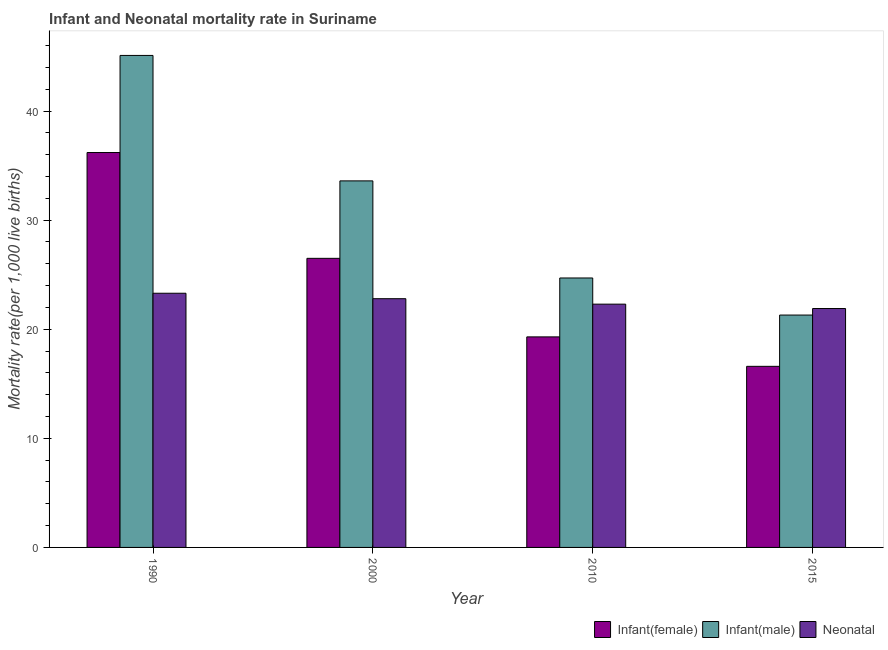How many groups of bars are there?
Give a very brief answer. 4. Are the number of bars on each tick of the X-axis equal?
Offer a terse response. Yes. How many bars are there on the 1st tick from the right?
Offer a very short reply. 3. What is the label of the 1st group of bars from the left?
Offer a very short reply. 1990. In how many cases, is the number of bars for a given year not equal to the number of legend labels?
Provide a short and direct response. 0. What is the neonatal mortality rate in 2010?
Keep it short and to the point. 22.3. Across all years, what is the maximum infant mortality rate(female)?
Ensure brevity in your answer.  36.2. Across all years, what is the minimum neonatal mortality rate?
Give a very brief answer. 21.9. In which year was the neonatal mortality rate maximum?
Provide a short and direct response. 1990. In which year was the infant mortality rate(female) minimum?
Your response must be concise. 2015. What is the total neonatal mortality rate in the graph?
Your response must be concise. 90.3. What is the difference between the neonatal mortality rate in 1990 and that in 2000?
Keep it short and to the point. 0.5. What is the difference between the neonatal mortality rate in 2015 and the infant mortality rate(male) in 2000?
Your response must be concise. -0.9. What is the average infant mortality rate(female) per year?
Ensure brevity in your answer.  24.65. What is the ratio of the infant mortality rate(male) in 2010 to that in 2015?
Your response must be concise. 1.16. Is the difference between the infant mortality rate(female) in 2000 and 2010 greater than the difference between the infant mortality rate(male) in 2000 and 2010?
Make the answer very short. No. What is the difference between the highest and the second highest infant mortality rate(female)?
Ensure brevity in your answer.  9.7. What is the difference between the highest and the lowest neonatal mortality rate?
Provide a short and direct response. 1.4. What does the 3rd bar from the left in 2000 represents?
Make the answer very short. Neonatal . What does the 2nd bar from the right in 2015 represents?
Your answer should be very brief. Infant(male). How many years are there in the graph?
Keep it short and to the point. 4. Does the graph contain grids?
Provide a short and direct response. No. Where does the legend appear in the graph?
Ensure brevity in your answer.  Bottom right. How many legend labels are there?
Provide a succinct answer. 3. How are the legend labels stacked?
Provide a short and direct response. Horizontal. What is the title of the graph?
Make the answer very short. Infant and Neonatal mortality rate in Suriname. What is the label or title of the Y-axis?
Your answer should be very brief. Mortality rate(per 1,0 live births). What is the Mortality rate(per 1,000 live births) in Infant(female) in 1990?
Keep it short and to the point. 36.2. What is the Mortality rate(per 1,000 live births) in Infant(male) in 1990?
Offer a very short reply. 45.1. What is the Mortality rate(per 1,000 live births) in Neonatal  in 1990?
Make the answer very short. 23.3. What is the Mortality rate(per 1,000 live births) in Infant(female) in 2000?
Your answer should be very brief. 26.5. What is the Mortality rate(per 1,000 live births) in Infant(male) in 2000?
Offer a very short reply. 33.6. What is the Mortality rate(per 1,000 live births) in Neonatal  in 2000?
Provide a succinct answer. 22.8. What is the Mortality rate(per 1,000 live births) in Infant(female) in 2010?
Your response must be concise. 19.3. What is the Mortality rate(per 1,000 live births) in Infant(male) in 2010?
Offer a very short reply. 24.7. What is the Mortality rate(per 1,000 live births) of Neonatal  in 2010?
Ensure brevity in your answer.  22.3. What is the Mortality rate(per 1,000 live births) of Infant(male) in 2015?
Make the answer very short. 21.3. What is the Mortality rate(per 1,000 live births) of Neonatal  in 2015?
Your answer should be compact. 21.9. Across all years, what is the maximum Mortality rate(per 1,000 live births) in Infant(female)?
Keep it short and to the point. 36.2. Across all years, what is the maximum Mortality rate(per 1,000 live births) in Infant(male)?
Make the answer very short. 45.1. Across all years, what is the maximum Mortality rate(per 1,000 live births) of Neonatal ?
Offer a very short reply. 23.3. Across all years, what is the minimum Mortality rate(per 1,000 live births) of Infant(female)?
Provide a short and direct response. 16.6. Across all years, what is the minimum Mortality rate(per 1,000 live births) of Infant(male)?
Your answer should be compact. 21.3. Across all years, what is the minimum Mortality rate(per 1,000 live births) in Neonatal ?
Your answer should be very brief. 21.9. What is the total Mortality rate(per 1,000 live births) in Infant(female) in the graph?
Provide a short and direct response. 98.6. What is the total Mortality rate(per 1,000 live births) of Infant(male) in the graph?
Your response must be concise. 124.7. What is the total Mortality rate(per 1,000 live births) in Neonatal  in the graph?
Give a very brief answer. 90.3. What is the difference between the Mortality rate(per 1,000 live births) of Infant(female) in 1990 and that in 2000?
Give a very brief answer. 9.7. What is the difference between the Mortality rate(per 1,000 live births) of Neonatal  in 1990 and that in 2000?
Your answer should be very brief. 0.5. What is the difference between the Mortality rate(per 1,000 live births) of Infant(female) in 1990 and that in 2010?
Your response must be concise. 16.9. What is the difference between the Mortality rate(per 1,000 live births) in Infant(male) in 1990 and that in 2010?
Give a very brief answer. 20.4. What is the difference between the Mortality rate(per 1,000 live births) in Neonatal  in 1990 and that in 2010?
Provide a short and direct response. 1. What is the difference between the Mortality rate(per 1,000 live births) in Infant(female) in 1990 and that in 2015?
Ensure brevity in your answer.  19.6. What is the difference between the Mortality rate(per 1,000 live births) in Infant(male) in 1990 and that in 2015?
Offer a very short reply. 23.8. What is the difference between the Mortality rate(per 1,000 live births) in Neonatal  in 2000 and that in 2010?
Offer a very short reply. 0.5. What is the difference between the Mortality rate(per 1,000 live births) in Infant(male) in 2000 and that in 2015?
Offer a very short reply. 12.3. What is the difference between the Mortality rate(per 1,000 live births) in Infant(female) in 2010 and that in 2015?
Provide a succinct answer. 2.7. What is the difference between the Mortality rate(per 1,000 live births) in Infant(male) in 2010 and that in 2015?
Provide a short and direct response. 3.4. What is the difference between the Mortality rate(per 1,000 live births) of Neonatal  in 2010 and that in 2015?
Ensure brevity in your answer.  0.4. What is the difference between the Mortality rate(per 1,000 live births) in Infant(female) in 1990 and the Mortality rate(per 1,000 live births) in Neonatal  in 2000?
Your answer should be compact. 13.4. What is the difference between the Mortality rate(per 1,000 live births) of Infant(male) in 1990 and the Mortality rate(per 1,000 live births) of Neonatal  in 2000?
Offer a very short reply. 22.3. What is the difference between the Mortality rate(per 1,000 live births) of Infant(female) in 1990 and the Mortality rate(per 1,000 live births) of Infant(male) in 2010?
Your response must be concise. 11.5. What is the difference between the Mortality rate(per 1,000 live births) of Infant(female) in 1990 and the Mortality rate(per 1,000 live births) of Neonatal  in 2010?
Your response must be concise. 13.9. What is the difference between the Mortality rate(per 1,000 live births) of Infant(male) in 1990 and the Mortality rate(per 1,000 live births) of Neonatal  in 2010?
Provide a succinct answer. 22.8. What is the difference between the Mortality rate(per 1,000 live births) of Infant(female) in 1990 and the Mortality rate(per 1,000 live births) of Infant(male) in 2015?
Provide a short and direct response. 14.9. What is the difference between the Mortality rate(per 1,000 live births) of Infant(female) in 1990 and the Mortality rate(per 1,000 live births) of Neonatal  in 2015?
Offer a terse response. 14.3. What is the difference between the Mortality rate(per 1,000 live births) of Infant(male) in 1990 and the Mortality rate(per 1,000 live births) of Neonatal  in 2015?
Offer a very short reply. 23.2. What is the difference between the Mortality rate(per 1,000 live births) in Infant(female) in 2000 and the Mortality rate(per 1,000 live births) in Neonatal  in 2010?
Keep it short and to the point. 4.2. What is the difference between the Mortality rate(per 1,000 live births) in Infant(male) in 2000 and the Mortality rate(per 1,000 live births) in Neonatal  in 2010?
Give a very brief answer. 11.3. What is the difference between the Mortality rate(per 1,000 live births) in Infant(female) in 2000 and the Mortality rate(per 1,000 live births) in Infant(male) in 2015?
Offer a terse response. 5.2. What is the difference between the Mortality rate(per 1,000 live births) in Infant(female) in 2000 and the Mortality rate(per 1,000 live births) in Neonatal  in 2015?
Give a very brief answer. 4.6. What is the average Mortality rate(per 1,000 live births) in Infant(female) per year?
Ensure brevity in your answer.  24.65. What is the average Mortality rate(per 1,000 live births) of Infant(male) per year?
Ensure brevity in your answer.  31.18. What is the average Mortality rate(per 1,000 live births) of Neonatal  per year?
Ensure brevity in your answer.  22.57. In the year 1990, what is the difference between the Mortality rate(per 1,000 live births) of Infant(female) and Mortality rate(per 1,000 live births) of Infant(male)?
Give a very brief answer. -8.9. In the year 1990, what is the difference between the Mortality rate(per 1,000 live births) of Infant(female) and Mortality rate(per 1,000 live births) of Neonatal ?
Your response must be concise. 12.9. In the year 1990, what is the difference between the Mortality rate(per 1,000 live births) of Infant(male) and Mortality rate(per 1,000 live births) of Neonatal ?
Offer a terse response. 21.8. In the year 2000, what is the difference between the Mortality rate(per 1,000 live births) in Infant(male) and Mortality rate(per 1,000 live births) in Neonatal ?
Your answer should be very brief. 10.8. In the year 2010, what is the difference between the Mortality rate(per 1,000 live births) of Infant(female) and Mortality rate(per 1,000 live births) of Infant(male)?
Offer a terse response. -5.4. In the year 2010, what is the difference between the Mortality rate(per 1,000 live births) of Infant(female) and Mortality rate(per 1,000 live births) of Neonatal ?
Your response must be concise. -3. In the year 2015, what is the difference between the Mortality rate(per 1,000 live births) of Infant(female) and Mortality rate(per 1,000 live births) of Neonatal ?
Give a very brief answer. -5.3. What is the ratio of the Mortality rate(per 1,000 live births) in Infant(female) in 1990 to that in 2000?
Ensure brevity in your answer.  1.37. What is the ratio of the Mortality rate(per 1,000 live births) in Infant(male) in 1990 to that in 2000?
Your answer should be compact. 1.34. What is the ratio of the Mortality rate(per 1,000 live births) in Neonatal  in 1990 to that in 2000?
Your answer should be compact. 1.02. What is the ratio of the Mortality rate(per 1,000 live births) in Infant(female) in 1990 to that in 2010?
Keep it short and to the point. 1.88. What is the ratio of the Mortality rate(per 1,000 live births) in Infant(male) in 1990 to that in 2010?
Offer a very short reply. 1.83. What is the ratio of the Mortality rate(per 1,000 live births) in Neonatal  in 1990 to that in 2010?
Make the answer very short. 1.04. What is the ratio of the Mortality rate(per 1,000 live births) of Infant(female) in 1990 to that in 2015?
Provide a short and direct response. 2.18. What is the ratio of the Mortality rate(per 1,000 live births) of Infant(male) in 1990 to that in 2015?
Keep it short and to the point. 2.12. What is the ratio of the Mortality rate(per 1,000 live births) of Neonatal  in 1990 to that in 2015?
Offer a terse response. 1.06. What is the ratio of the Mortality rate(per 1,000 live births) in Infant(female) in 2000 to that in 2010?
Your answer should be compact. 1.37. What is the ratio of the Mortality rate(per 1,000 live births) of Infant(male) in 2000 to that in 2010?
Make the answer very short. 1.36. What is the ratio of the Mortality rate(per 1,000 live births) of Neonatal  in 2000 to that in 2010?
Provide a succinct answer. 1.02. What is the ratio of the Mortality rate(per 1,000 live births) of Infant(female) in 2000 to that in 2015?
Your answer should be compact. 1.6. What is the ratio of the Mortality rate(per 1,000 live births) of Infant(male) in 2000 to that in 2015?
Provide a succinct answer. 1.58. What is the ratio of the Mortality rate(per 1,000 live births) of Neonatal  in 2000 to that in 2015?
Keep it short and to the point. 1.04. What is the ratio of the Mortality rate(per 1,000 live births) in Infant(female) in 2010 to that in 2015?
Your response must be concise. 1.16. What is the ratio of the Mortality rate(per 1,000 live births) of Infant(male) in 2010 to that in 2015?
Ensure brevity in your answer.  1.16. What is the ratio of the Mortality rate(per 1,000 live births) in Neonatal  in 2010 to that in 2015?
Provide a short and direct response. 1.02. What is the difference between the highest and the lowest Mortality rate(per 1,000 live births) of Infant(female)?
Your answer should be very brief. 19.6. What is the difference between the highest and the lowest Mortality rate(per 1,000 live births) of Infant(male)?
Make the answer very short. 23.8. 